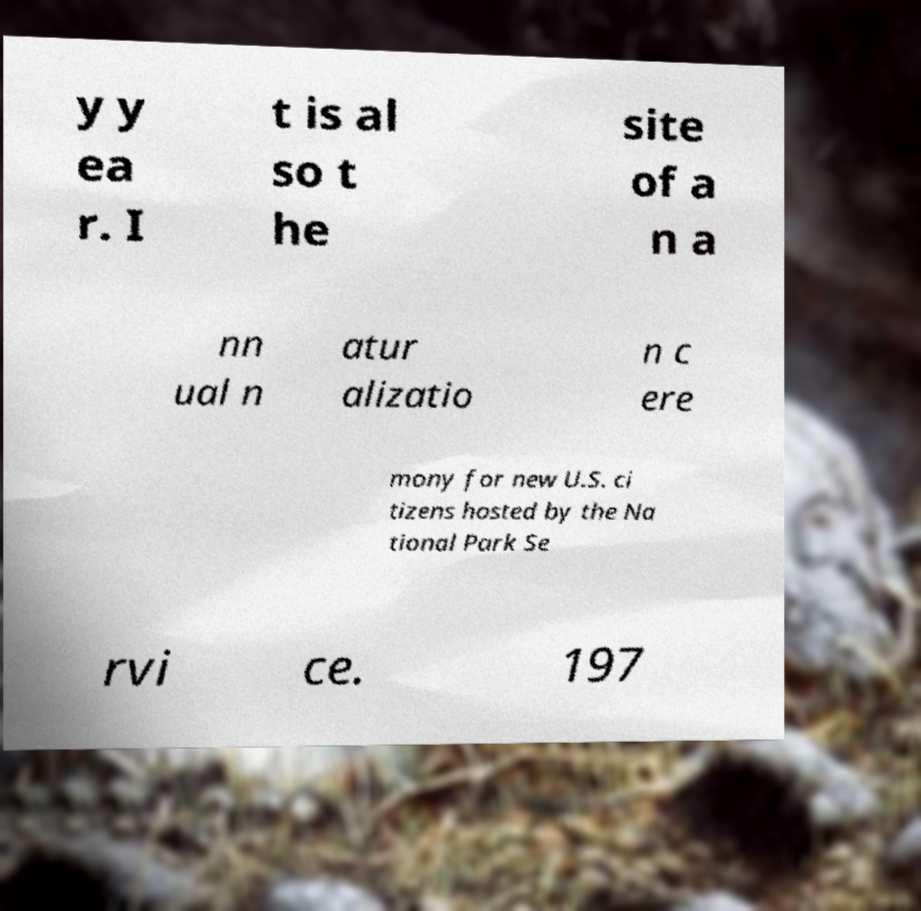Can you read and provide the text displayed in the image?This photo seems to have some interesting text. Can you extract and type it out for me? y y ea r. I t is al so t he site of a n a nn ual n atur alizatio n c ere mony for new U.S. ci tizens hosted by the Na tional Park Se rvi ce. 197 